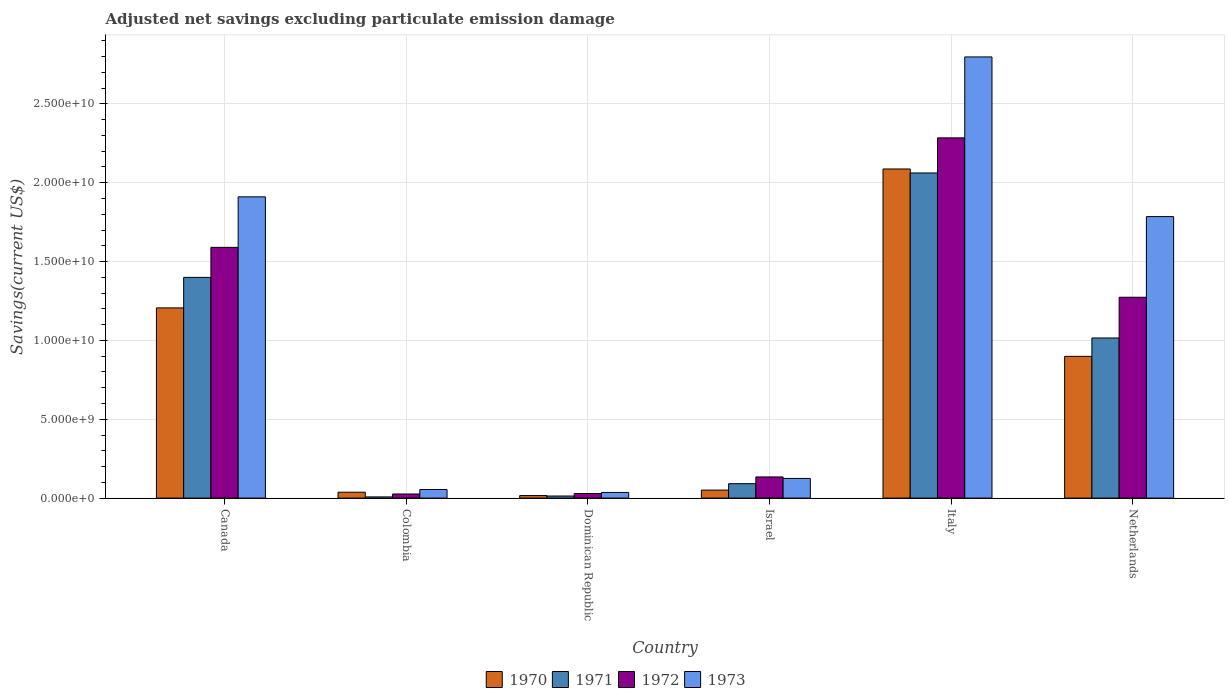How many groups of bars are there?
Your answer should be compact. 6. How many bars are there on the 5th tick from the left?
Provide a succinct answer. 4. What is the label of the 5th group of bars from the left?
Give a very brief answer. Italy. In how many cases, is the number of bars for a given country not equal to the number of legend labels?
Offer a very short reply. 0. What is the adjusted net savings in 1971 in Israel?
Keep it short and to the point. 9.14e+08. Across all countries, what is the maximum adjusted net savings in 1972?
Provide a short and direct response. 2.28e+1. Across all countries, what is the minimum adjusted net savings in 1972?
Your answer should be compact. 2.60e+08. In which country was the adjusted net savings in 1970 minimum?
Provide a short and direct response. Dominican Republic. What is the total adjusted net savings in 1973 in the graph?
Make the answer very short. 6.71e+1. What is the difference between the adjusted net savings in 1971 in Dominican Republic and that in Italy?
Make the answer very short. -2.05e+1. What is the difference between the adjusted net savings in 1971 in Netherlands and the adjusted net savings in 1970 in Colombia?
Offer a very short reply. 9.78e+09. What is the average adjusted net savings in 1973 per country?
Ensure brevity in your answer.  1.12e+1. What is the difference between the adjusted net savings of/in 1972 and adjusted net savings of/in 1970 in Canada?
Provide a short and direct response. 3.84e+09. What is the ratio of the adjusted net savings in 1973 in Israel to that in Italy?
Provide a succinct answer. 0.04. Is the adjusted net savings in 1971 in Canada less than that in Netherlands?
Make the answer very short. No. Is the difference between the adjusted net savings in 1972 in Italy and Netherlands greater than the difference between the adjusted net savings in 1970 in Italy and Netherlands?
Your response must be concise. No. What is the difference between the highest and the second highest adjusted net savings in 1972?
Ensure brevity in your answer.  1.01e+1. What is the difference between the highest and the lowest adjusted net savings in 1970?
Give a very brief answer. 2.07e+1. In how many countries, is the adjusted net savings in 1971 greater than the average adjusted net savings in 1971 taken over all countries?
Provide a short and direct response. 3. Is the sum of the adjusted net savings in 1973 in Colombia and Israel greater than the maximum adjusted net savings in 1972 across all countries?
Make the answer very short. No. What does the 2nd bar from the left in Colombia represents?
Make the answer very short. 1971. Is it the case that in every country, the sum of the adjusted net savings in 1972 and adjusted net savings in 1971 is greater than the adjusted net savings in 1973?
Your answer should be compact. No. How many bars are there?
Provide a succinct answer. 24. Where does the legend appear in the graph?
Provide a succinct answer. Bottom center. How many legend labels are there?
Your response must be concise. 4. What is the title of the graph?
Keep it short and to the point. Adjusted net savings excluding particulate emission damage. What is the label or title of the Y-axis?
Give a very brief answer. Savings(current US$). What is the Savings(current US$) of 1970 in Canada?
Offer a terse response. 1.21e+1. What is the Savings(current US$) in 1971 in Canada?
Give a very brief answer. 1.40e+1. What is the Savings(current US$) in 1972 in Canada?
Offer a very short reply. 1.59e+1. What is the Savings(current US$) in 1973 in Canada?
Make the answer very short. 1.91e+1. What is the Savings(current US$) of 1970 in Colombia?
Give a very brief answer. 3.74e+08. What is the Savings(current US$) of 1971 in Colombia?
Your answer should be compact. 7.46e+07. What is the Savings(current US$) in 1972 in Colombia?
Offer a terse response. 2.60e+08. What is the Savings(current US$) in 1973 in Colombia?
Make the answer very short. 5.45e+08. What is the Savings(current US$) of 1970 in Dominican Republic?
Provide a succinct answer. 1.61e+08. What is the Savings(current US$) of 1971 in Dominican Republic?
Keep it short and to the point. 1.32e+08. What is the Savings(current US$) in 1972 in Dominican Republic?
Provide a short and direct response. 2.89e+08. What is the Savings(current US$) of 1973 in Dominican Republic?
Your response must be concise. 3.58e+08. What is the Savings(current US$) of 1970 in Israel?
Make the answer very short. 5.08e+08. What is the Savings(current US$) of 1971 in Israel?
Make the answer very short. 9.14e+08. What is the Savings(current US$) of 1972 in Israel?
Your response must be concise. 1.34e+09. What is the Savings(current US$) of 1973 in Israel?
Give a very brief answer. 1.25e+09. What is the Savings(current US$) of 1970 in Italy?
Make the answer very short. 2.09e+1. What is the Savings(current US$) in 1971 in Italy?
Provide a succinct answer. 2.06e+1. What is the Savings(current US$) of 1972 in Italy?
Offer a very short reply. 2.28e+1. What is the Savings(current US$) of 1973 in Italy?
Provide a succinct answer. 2.80e+1. What is the Savings(current US$) of 1970 in Netherlands?
Your answer should be compact. 8.99e+09. What is the Savings(current US$) in 1971 in Netherlands?
Provide a succinct answer. 1.02e+1. What is the Savings(current US$) in 1972 in Netherlands?
Make the answer very short. 1.27e+1. What is the Savings(current US$) of 1973 in Netherlands?
Provide a short and direct response. 1.79e+1. Across all countries, what is the maximum Savings(current US$) of 1970?
Offer a very short reply. 2.09e+1. Across all countries, what is the maximum Savings(current US$) in 1971?
Ensure brevity in your answer.  2.06e+1. Across all countries, what is the maximum Savings(current US$) of 1972?
Ensure brevity in your answer.  2.28e+1. Across all countries, what is the maximum Savings(current US$) of 1973?
Offer a very short reply. 2.80e+1. Across all countries, what is the minimum Savings(current US$) of 1970?
Provide a short and direct response. 1.61e+08. Across all countries, what is the minimum Savings(current US$) of 1971?
Give a very brief answer. 7.46e+07. Across all countries, what is the minimum Savings(current US$) of 1972?
Your answer should be compact. 2.60e+08. Across all countries, what is the minimum Savings(current US$) of 1973?
Offer a terse response. 3.58e+08. What is the total Savings(current US$) of 1970 in the graph?
Make the answer very short. 4.30e+1. What is the total Savings(current US$) in 1971 in the graph?
Your response must be concise. 4.59e+1. What is the total Savings(current US$) in 1972 in the graph?
Your answer should be compact. 5.34e+1. What is the total Savings(current US$) in 1973 in the graph?
Provide a succinct answer. 6.71e+1. What is the difference between the Savings(current US$) of 1970 in Canada and that in Colombia?
Give a very brief answer. 1.17e+1. What is the difference between the Savings(current US$) in 1971 in Canada and that in Colombia?
Make the answer very short. 1.39e+1. What is the difference between the Savings(current US$) of 1972 in Canada and that in Colombia?
Your answer should be compact. 1.56e+1. What is the difference between the Savings(current US$) in 1973 in Canada and that in Colombia?
Offer a terse response. 1.86e+1. What is the difference between the Savings(current US$) of 1970 in Canada and that in Dominican Republic?
Your response must be concise. 1.19e+1. What is the difference between the Savings(current US$) of 1971 in Canada and that in Dominican Republic?
Ensure brevity in your answer.  1.39e+1. What is the difference between the Savings(current US$) in 1972 in Canada and that in Dominican Republic?
Make the answer very short. 1.56e+1. What is the difference between the Savings(current US$) in 1973 in Canada and that in Dominican Republic?
Offer a terse response. 1.87e+1. What is the difference between the Savings(current US$) of 1970 in Canada and that in Israel?
Your response must be concise. 1.16e+1. What is the difference between the Savings(current US$) in 1971 in Canada and that in Israel?
Your answer should be compact. 1.31e+1. What is the difference between the Savings(current US$) of 1972 in Canada and that in Israel?
Your response must be concise. 1.46e+1. What is the difference between the Savings(current US$) of 1973 in Canada and that in Israel?
Offer a terse response. 1.79e+1. What is the difference between the Savings(current US$) in 1970 in Canada and that in Italy?
Ensure brevity in your answer.  -8.81e+09. What is the difference between the Savings(current US$) in 1971 in Canada and that in Italy?
Offer a very short reply. -6.62e+09. What is the difference between the Savings(current US$) of 1972 in Canada and that in Italy?
Provide a succinct answer. -6.94e+09. What is the difference between the Savings(current US$) of 1973 in Canada and that in Italy?
Make the answer very short. -8.87e+09. What is the difference between the Savings(current US$) in 1970 in Canada and that in Netherlands?
Offer a terse response. 3.07e+09. What is the difference between the Savings(current US$) in 1971 in Canada and that in Netherlands?
Your answer should be compact. 3.84e+09. What is the difference between the Savings(current US$) of 1972 in Canada and that in Netherlands?
Keep it short and to the point. 3.16e+09. What is the difference between the Savings(current US$) in 1973 in Canada and that in Netherlands?
Offer a very short reply. 1.25e+09. What is the difference between the Savings(current US$) of 1970 in Colombia and that in Dominican Republic?
Your answer should be compact. 2.13e+08. What is the difference between the Savings(current US$) in 1971 in Colombia and that in Dominican Republic?
Provide a short and direct response. -5.69e+07. What is the difference between the Savings(current US$) in 1972 in Colombia and that in Dominican Republic?
Offer a terse response. -2.84e+07. What is the difference between the Savings(current US$) in 1973 in Colombia and that in Dominican Republic?
Your answer should be very brief. 1.87e+08. What is the difference between the Savings(current US$) of 1970 in Colombia and that in Israel?
Your answer should be very brief. -1.34e+08. What is the difference between the Savings(current US$) in 1971 in Colombia and that in Israel?
Provide a short and direct response. -8.40e+08. What is the difference between the Savings(current US$) in 1972 in Colombia and that in Israel?
Your answer should be compact. -1.08e+09. What is the difference between the Savings(current US$) in 1973 in Colombia and that in Israel?
Offer a terse response. -7.02e+08. What is the difference between the Savings(current US$) of 1970 in Colombia and that in Italy?
Your answer should be very brief. -2.05e+1. What is the difference between the Savings(current US$) of 1971 in Colombia and that in Italy?
Make the answer very short. -2.05e+1. What is the difference between the Savings(current US$) of 1972 in Colombia and that in Italy?
Keep it short and to the point. -2.26e+1. What is the difference between the Savings(current US$) in 1973 in Colombia and that in Italy?
Keep it short and to the point. -2.74e+1. What is the difference between the Savings(current US$) of 1970 in Colombia and that in Netherlands?
Offer a very short reply. -8.61e+09. What is the difference between the Savings(current US$) in 1971 in Colombia and that in Netherlands?
Your answer should be compact. -1.01e+1. What is the difference between the Savings(current US$) in 1972 in Colombia and that in Netherlands?
Your answer should be compact. -1.25e+1. What is the difference between the Savings(current US$) of 1973 in Colombia and that in Netherlands?
Provide a short and direct response. -1.73e+1. What is the difference between the Savings(current US$) of 1970 in Dominican Republic and that in Israel?
Offer a terse response. -3.47e+08. What is the difference between the Savings(current US$) of 1971 in Dominican Republic and that in Israel?
Ensure brevity in your answer.  -7.83e+08. What is the difference between the Savings(current US$) of 1972 in Dominican Republic and that in Israel?
Make the answer very short. -1.05e+09. What is the difference between the Savings(current US$) in 1973 in Dominican Republic and that in Israel?
Keep it short and to the point. -8.89e+08. What is the difference between the Savings(current US$) in 1970 in Dominican Republic and that in Italy?
Offer a terse response. -2.07e+1. What is the difference between the Savings(current US$) of 1971 in Dominican Republic and that in Italy?
Keep it short and to the point. -2.05e+1. What is the difference between the Savings(current US$) in 1972 in Dominican Republic and that in Italy?
Ensure brevity in your answer.  -2.26e+1. What is the difference between the Savings(current US$) in 1973 in Dominican Republic and that in Italy?
Your answer should be compact. -2.76e+1. What is the difference between the Savings(current US$) in 1970 in Dominican Republic and that in Netherlands?
Ensure brevity in your answer.  -8.83e+09. What is the difference between the Savings(current US$) of 1971 in Dominican Republic and that in Netherlands?
Give a very brief answer. -1.00e+1. What is the difference between the Savings(current US$) in 1972 in Dominican Republic and that in Netherlands?
Your response must be concise. -1.24e+1. What is the difference between the Savings(current US$) of 1973 in Dominican Republic and that in Netherlands?
Your answer should be compact. -1.75e+1. What is the difference between the Savings(current US$) of 1970 in Israel and that in Italy?
Your answer should be compact. -2.04e+1. What is the difference between the Savings(current US$) of 1971 in Israel and that in Italy?
Offer a very short reply. -1.97e+1. What is the difference between the Savings(current US$) of 1972 in Israel and that in Italy?
Ensure brevity in your answer.  -2.15e+1. What is the difference between the Savings(current US$) of 1973 in Israel and that in Italy?
Provide a succinct answer. -2.67e+1. What is the difference between the Savings(current US$) of 1970 in Israel and that in Netherlands?
Ensure brevity in your answer.  -8.48e+09. What is the difference between the Savings(current US$) in 1971 in Israel and that in Netherlands?
Offer a very short reply. -9.24e+09. What is the difference between the Savings(current US$) of 1972 in Israel and that in Netherlands?
Your answer should be very brief. -1.14e+1. What is the difference between the Savings(current US$) of 1973 in Israel and that in Netherlands?
Offer a very short reply. -1.66e+1. What is the difference between the Savings(current US$) in 1970 in Italy and that in Netherlands?
Keep it short and to the point. 1.19e+1. What is the difference between the Savings(current US$) in 1971 in Italy and that in Netherlands?
Make the answer very short. 1.05e+1. What is the difference between the Savings(current US$) in 1972 in Italy and that in Netherlands?
Provide a succinct answer. 1.01e+1. What is the difference between the Savings(current US$) of 1973 in Italy and that in Netherlands?
Keep it short and to the point. 1.01e+1. What is the difference between the Savings(current US$) of 1970 in Canada and the Savings(current US$) of 1971 in Colombia?
Make the answer very short. 1.20e+1. What is the difference between the Savings(current US$) in 1970 in Canada and the Savings(current US$) in 1972 in Colombia?
Give a very brief answer. 1.18e+1. What is the difference between the Savings(current US$) of 1970 in Canada and the Savings(current US$) of 1973 in Colombia?
Your answer should be very brief. 1.15e+1. What is the difference between the Savings(current US$) in 1971 in Canada and the Savings(current US$) in 1972 in Colombia?
Your answer should be compact. 1.37e+1. What is the difference between the Savings(current US$) of 1971 in Canada and the Savings(current US$) of 1973 in Colombia?
Provide a succinct answer. 1.35e+1. What is the difference between the Savings(current US$) in 1972 in Canada and the Savings(current US$) in 1973 in Colombia?
Offer a terse response. 1.54e+1. What is the difference between the Savings(current US$) of 1970 in Canada and the Savings(current US$) of 1971 in Dominican Republic?
Offer a very short reply. 1.19e+1. What is the difference between the Savings(current US$) of 1970 in Canada and the Savings(current US$) of 1972 in Dominican Republic?
Keep it short and to the point. 1.18e+1. What is the difference between the Savings(current US$) in 1970 in Canada and the Savings(current US$) in 1973 in Dominican Republic?
Your answer should be very brief. 1.17e+1. What is the difference between the Savings(current US$) of 1971 in Canada and the Savings(current US$) of 1972 in Dominican Republic?
Your answer should be compact. 1.37e+1. What is the difference between the Savings(current US$) in 1971 in Canada and the Savings(current US$) in 1973 in Dominican Republic?
Ensure brevity in your answer.  1.36e+1. What is the difference between the Savings(current US$) in 1972 in Canada and the Savings(current US$) in 1973 in Dominican Republic?
Offer a terse response. 1.55e+1. What is the difference between the Savings(current US$) in 1970 in Canada and the Savings(current US$) in 1971 in Israel?
Your response must be concise. 1.11e+1. What is the difference between the Savings(current US$) in 1970 in Canada and the Savings(current US$) in 1972 in Israel?
Offer a terse response. 1.07e+1. What is the difference between the Savings(current US$) in 1970 in Canada and the Savings(current US$) in 1973 in Israel?
Give a very brief answer. 1.08e+1. What is the difference between the Savings(current US$) of 1971 in Canada and the Savings(current US$) of 1972 in Israel?
Keep it short and to the point. 1.27e+1. What is the difference between the Savings(current US$) of 1971 in Canada and the Savings(current US$) of 1973 in Israel?
Give a very brief answer. 1.27e+1. What is the difference between the Savings(current US$) of 1972 in Canada and the Savings(current US$) of 1973 in Israel?
Provide a short and direct response. 1.47e+1. What is the difference between the Savings(current US$) of 1970 in Canada and the Savings(current US$) of 1971 in Italy?
Ensure brevity in your answer.  -8.56e+09. What is the difference between the Savings(current US$) in 1970 in Canada and the Savings(current US$) in 1972 in Italy?
Offer a terse response. -1.08e+1. What is the difference between the Savings(current US$) of 1970 in Canada and the Savings(current US$) of 1973 in Italy?
Provide a succinct answer. -1.59e+1. What is the difference between the Savings(current US$) of 1971 in Canada and the Savings(current US$) of 1972 in Italy?
Your response must be concise. -8.85e+09. What is the difference between the Savings(current US$) in 1971 in Canada and the Savings(current US$) in 1973 in Italy?
Ensure brevity in your answer.  -1.40e+1. What is the difference between the Savings(current US$) in 1972 in Canada and the Savings(current US$) in 1973 in Italy?
Ensure brevity in your answer.  -1.21e+1. What is the difference between the Savings(current US$) of 1970 in Canada and the Savings(current US$) of 1971 in Netherlands?
Provide a short and direct response. 1.91e+09. What is the difference between the Savings(current US$) in 1970 in Canada and the Savings(current US$) in 1972 in Netherlands?
Provide a succinct answer. -6.74e+08. What is the difference between the Savings(current US$) of 1970 in Canada and the Savings(current US$) of 1973 in Netherlands?
Offer a very short reply. -5.79e+09. What is the difference between the Savings(current US$) in 1971 in Canada and the Savings(current US$) in 1972 in Netherlands?
Ensure brevity in your answer.  1.26e+09. What is the difference between the Savings(current US$) in 1971 in Canada and the Savings(current US$) in 1973 in Netherlands?
Offer a terse response. -3.85e+09. What is the difference between the Savings(current US$) of 1972 in Canada and the Savings(current US$) of 1973 in Netherlands?
Keep it short and to the point. -1.95e+09. What is the difference between the Savings(current US$) in 1970 in Colombia and the Savings(current US$) in 1971 in Dominican Republic?
Offer a terse response. 2.42e+08. What is the difference between the Savings(current US$) in 1970 in Colombia and the Savings(current US$) in 1972 in Dominican Republic?
Ensure brevity in your answer.  8.52e+07. What is the difference between the Savings(current US$) in 1970 in Colombia and the Savings(current US$) in 1973 in Dominican Republic?
Your response must be concise. 1.57e+07. What is the difference between the Savings(current US$) of 1971 in Colombia and the Savings(current US$) of 1972 in Dominican Republic?
Your response must be concise. -2.14e+08. What is the difference between the Savings(current US$) in 1971 in Colombia and the Savings(current US$) in 1973 in Dominican Republic?
Your answer should be very brief. -2.84e+08. What is the difference between the Savings(current US$) of 1972 in Colombia and the Savings(current US$) of 1973 in Dominican Republic?
Your response must be concise. -9.79e+07. What is the difference between the Savings(current US$) in 1970 in Colombia and the Savings(current US$) in 1971 in Israel?
Your response must be concise. -5.40e+08. What is the difference between the Savings(current US$) in 1970 in Colombia and the Savings(current US$) in 1972 in Israel?
Your answer should be very brief. -9.67e+08. What is the difference between the Savings(current US$) of 1970 in Colombia and the Savings(current US$) of 1973 in Israel?
Your response must be concise. -8.73e+08. What is the difference between the Savings(current US$) of 1971 in Colombia and the Savings(current US$) of 1972 in Israel?
Keep it short and to the point. -1.27e+09. What is the difference between the Savings(current US$) in 1971 in Colombia and the Savings(current US$) in 1973 in Israel?
Your answer should be very brief. -1.17e+09. What is the difference between the Savings(current US$) in 1972 in Colombia and the Savings(current US$) in 1973 in Israel?
Give a very brief answer. -9.87e+08. What is the difference between the Savings(current US$) of 1970 in Colombia and the Savings(current US$) of 1971 in Italy?
Provide a short and direct response. -2.02e+1. What is the difference between the Savings(current US$) of 1970 in Colombia and the Savings(current US$) of 1972 in Italy?
Keep it short and to the point. -2.25e+1. What is the difference between the Savings(current US$) of 1970 in Colombia and the Savings(current US$) of 1973 in Italy?
Make the answer very short. -2.76e+1. What is the difference between the Savings(current US$) in 1971 in Colombia and the Savings(current US$) in 1972 in Italy?
Offer a very short reply. -2.28e+1. What is the difference between the Savings(current US$) in 1971 in Colombia and the Savings(current US$) in 1973 in Italy?
Provide a succinct answer. -2.79e+1. What is the difference between the Savings(current US$) in 1972 in Colombia and the Savings(current US$) in 1973 in Italy?
Ensure brevity in your answer.  -2.77e+1. What is the difference between the Savings(current US$) of 1970 in Colombia and the Savings(current US$) of 1971 in Netherlands?
Provide a short and direct response. -9.78e+09. What is the difference between the Savings(current US$) of 1970 in Colombia and the Savings(current US$) of 1972 in Netherlands?
Provide a short and direct response. -1.24e+1. What is the difference between the Savings(current US$) in 1970 in Colombia and the Savings(current US$) in 1973 in Netherlands?
Keep it short and to the point. -1.75e+1. What is the difference between the Savings(current US$) of 1971 in Colombia and the Savings(current US$) of 1972 in Netherlands?
Your response must be concise. -1.27e+1. What is the difference between the Savings(current US$) of 1971 in Colombia and the Savings(current US$) of 1973 in Netherlands?
Ensure brevity in your answer.  -1.78e+1. What is the difference between the Savings(current US$) in 1972 in Colombia and the Savings(current US$) in 1973 in Netherlands?
Provide a short and direct response. -1.76e+1. What is the difference between the Savings(current US$) of 1970 in Dominican Republic and the Savings(current US$) of 1971 in Israel?
Your answer should be very brief. -7.53e+08. What is the difference between the Savings(current US$) in 1970 in Dominican Republic and the Savings(current US$) in 1972 in Israel?
Offer a terse response. -1.18e+09. What is the difference between the Savings(current US$) in 1970 in Dominican Republic and the Savings(current US$) in 1973 in Israel?
Ensure brevity in your answer.  -1.09e+09. What is the difference between the Savings(current US$) in 1971 in Dominican Republic and the Savings(current US$) in 1972 in Israel?
Ensure brevity in your answer.  -1.21e+09. What is the difference between the Savings(current US$) in 1971 in Dominican Republic and the Savings(current US$) in 1973 in Israel?
Give a very brief answer. -1.12e+09. What is the difference between the Savings(current US$) of 1972 in Dominican Republic and the Savings(current US$) of 1973 in Israel?
Keep it short and to the point. -9.58e+08. What is the difference between the Savings(current US$) of 1970 in Dominican Republic and the Savings(current US$) of 1971 in Italy?
Your answer should be very brief. -2.05e+1. What is the difference between the Savings(current US$) in 1970 in Dominican Republic and the Savings(current US$) in 1972 in Italy?
Provide a succinct answer. -2.27e+1. What is the difference between the Savings(current US$) of 1970 in Dominican Republic and the Savings(current US$) of 1973 in Italy?
Provide a succinct answer. -2.78e+1. What is the difference between the Savings(current US$) in 1971 in Dominican Republic and the Savings(current US$) in 1972 in Italy?
Your response must be concise. -2.27e+1. What is the difference between the Savings(current US$) of 1971 in Dominican Republic and the Savings(current US$) of 1973 in Italy?
Offer a terse response. -2.78e+1. What is the difference between the Savings(current US$) in 1972 in Dominican Republic and the Savings(current US$) in 1973 in Italy?
Offer a very short reply. -2.77e+1. What is the difference between the Savings(current US$) of 1970 in Dominican Republic and the Savings(current US$) of 1971 in Netherlands?
Your response must be concise. -9.99e+09. What is the difference between the Savings(current US$) of 1970 in Dominican Republic and the Savings(current US$) of 1972 in Netherlands?
Ensure brevity in your answer.  -1.26e+1. What is the difference between the Savings(current US$) in 1970 in Dominican Republic and the Savings(current US$) in 1973 in Netherlands?
Provide a succinct answer. -1.77e+1. What is the difference between the Savings(current US$) of 1971 in Dominican Republic and the Savings(current US$) of 1972 in Netherlands?
Your answer should be compact. -1.26e+1. What is the difference between the Savings(current US$) in 1971 in Dominican Republic and the Savings(current US$) in 1973 in Netherlands?
Give a very brief answer. -1.77e+1. What is the difference between the Savings(current US$) in 1972 in Dominican Republic and the Savings(current US$) in 1973 in Netherlands?
Provide a short and direct response. -1.76e+1. What is the difference between the Savings(current US$) in 1970 in Israel and the Savings(current US$) in 1971 in Italy?
Your answer should be very brief. -2.01e+1. What is the difference between the Savings(current US$) of 1970 in Israel and the Savings(current US$) of 1972 in Italy?
Keep it short and to the point. -2.23e+1. What is the difference between the Savings(current US$) of 1970 in Israel and the Savings(current US$) of 1973 in Italy?
Provide a succinct answer. -2.75e+1. What is the difference between the Savings(current US$) in 1971 in Israel and the Savings(current US$) in 1972 in Italy?
Your answer should be very brief. -2.19e+1. What is the difference between the Savings(current US$) in 1971 in Israel and the Savings(current US$) in 1973 in Italy?
Keep it short and to the point. -2.71e+1. What is the difference between the Savings(current US$) of 1972 in Israel and the Savings(current US$) of 1973 in Italy?
Offer a terse response. -2.66e+1. What is the difference between the Savings(current US$) of 1970 in Israel and the Savings(current US$) of 1971 in Netherlands?
Keep it short and to the point. -9.65e+09. What is the difference between the Savings(current US$) of 1970 in Israel and the Savings(current US$) of 1972 in Netherlands?
Offer a terse response. -1.22e+1. What is the difference between the Savings(current US$) in 1970 in Israel and the Savings(current US$) in 1973 in Netherlands?
Provide a short and direct response. -1.73e+1. What is the difference between the Savings(current US$) of 1971 in Israel and the Savings(current US$) of 1972 in Netherlands?
Your answer should be compact. -1.18e+1. What is the difference between the Savings(current US$) of 1971 in Israel and the Savings(current US$) of 1973 in Netherlands?
Make the answer very short. -1.69e+1. What is the difference between the Savings(current US$) of 1972 in Israel and the Savings(current US$) of 1973 in Netherlands?
Provide a succinct answer. -1.65e+1. What is the difference between the Savings(current US$) of 1970 in Italy and the Savings(current US$) of 1971 in Netherlands?
Provide a succinct answer. 1.07e+1. What is the difference between the Savings(current US$) in 1970 in Italy and the Savings(current US$) in 1972 in Netherlands?
Your answer should be very brief. 8.14e+09. What is the difference between the Savings(current US$) in 1970 in Italy and the Savings(current US$) in 1973 in Netherlands?
Give a very brief answer. 3.02e+09. What is the difference between the Savings(current US$) in 1971 in Italy and the Savings(current US$) in 1972 in Netherlands?
Ensure brevity in your answer.  7.88e+09. What is the difference between the Savings(current US$) in 1971 in Italy and the Savings(current US$) in 1973 in Netherlands?
Your answer should be very brief. 2.77e+09. What is the difference between the Savings(current US$) in 1972 in Italy and the Savings(current US$) in 1973 in Netherlands?
Ensure brevity in your answer.  4.99e+09. What is the average Savings(current US$) of 1970 per country?
Give a very brief answer. 7.16e+09. What is the average Savings(current US$) in 1971 per country?
Offer a terse response. 7.65e+09. What is the average Savings(current US$) of 1972 per country?
Make the answer very short. 8.89e+09. What is the average Savings(current US$) in 1973 per country?
Keep it short and to the point. 1.12e+1. What is the difference between the Savings(current US$) of 1970 and Savings(current US$) of 1971 in Canada?
Your response must be concise. -1.94e+09. What is the difference between the Savings(current US$) in 1970 and Savings(current US$) in 1972 in Canada?
Keep it short and to the point. -3.84e+09. What is the difference between the Savings(current US$) in 1970 and Savings(current US$) in 1973 in Canada?
Offer a terse response. -7.04e+09. What is the difference between the Savings(current US$) in 1971 and Savings(current US$) in 1972 in Canada?
Offer a terse response. -1.90e+09. What is the difference between the Savings(current US$) in 1971 and Savings(current US$) in 1973 in Canada?
Your response must be concise. -5.11e+09. What is the difference between the Savings(current US$) of 1972 and Savings(current US$) of 1973 in Canada?
Make the answer very short. -3.20e+09. What is the difference between the Savings(current US$) of 1970 and Savings(current US$) of 1971 in Colombia?
Your answer should be compact. 2.99e+08. What is the difference between the Savings(current US$) in 1970 and Savings(current US$) in 1972 in Colombia?
Your response must be concise. 1.14e+08. What is the difference between the Savings(current US$) in 1970 and Savings(current US$) in 1973 in Colombia?
Provide a short and direct response. -1.71e+08. What is the difference between the Savings(current US$) in 1971 and Savings(current US$) in 1972 in Colombia?
Your answer should be very brief. -1.86e+08. What is the difference between the Savings(current US$) of 1971 and Savings(current US$) of 1973 in Colombia?
Offer a terse response. -4.70e+08. What is the difference between the Savings(current US$) in 1972 and Savings(current US$) in 1973 in Colombia?
Make the answer very short. -2.85e+08. What is the difference between the Savings(current US$) in 1970 and Savings(current US$) in 1971 in Dominican Republic?
Ensure brevity in your answer.  2.96e+07. What is the difference between the Savings(current US$) of 1970 and Savings(current US$) of 1972 in Dominican Republic?
Provide a succinct answer. -1.28e+08. What is the difference between the Savings(current US$) in 1970 and Savings(current US$) in 1973 in Dominican Republic?
Make the answer very short. -1.97e+08. What is the difference between the Savings(current US$) of 1971 and Savings(current US$) of 1972 in Dominican Republic?
Give a very brief answer. -1.57e+08. What is the difference between the Savings(current US$) of 1971 and Savings(current US$) of 1973 in Dominican Republic?
Your response must be concise. -2.27e+08. What is the difference between the Savings(current US$) of 1972 and Savings(current US$) of 1973 in Dominican Republic?
Your answer should be very brief. -6.95e+07. What is the difference between the Savings(current US$) of 1970 and Savings(current US$) of 1971 in Israel?
Provide a succinct answer. -4.06e+08. What is the difference between the Savings(current US$) of 1970 and Savings(current US$) of 1972 in Israel?
Keep it short and to the point. -8.33e+08. What is the difference between the Savings(current US$) in 1970 and Savings(current US$) in 1973 in Israel?
Make the answer very short. -7.39e+08. What is the difference between the Savings(current US$) in 1971 and Savings(current US$) in 1972 in Israel?
Offer a very short reply. -4.27e+08. What is the difference between the Savings(current US$) of 1971 and Savings(current US$) of 1973 in Israel?
Offer a terse response. -3.33e+08. What is the difference between the Savings(current US$) of 1972 and Savings(current US$) of 1973 in Israel?
Ensure brevity in your answer.  9.40e+07. What is the difference between the Savings(current US$) in 1970 and Savings(current US$) in 1971 in Italy?
Give a very brief answer. 2.53e+08. What is the difference between the Savings(current US$) in 1970 and Savings(current US$) in 1972 in Italy?
Your answer should be compact. -1.97e+09. What is the difference between the Savings(current US$) of 1970 and Savings(current US$) of 1973 in Italy?
Ensure brevity in your answer.  -7.11e+09. What is the difference between the Savings(current US$) in 1971 and Savings(current US$) in 1972 in Italy?
Your answer should be compact. -2.23e+09. What is the difference between the Savings(current US$) in 1971 and Savings(current US$) in 1973 in Italy?
Provide a short and direct response. -7.36e+09. What is the difference between the Savings(current US$) in 1972 and Savings(current US$) in 1973 in Italy?
Provide a succinct answer. -5.13e+09. What is the difference between the Savings(current US$) of 1970 and Savings(current US$) of 1971 in Netherlands?
Your answer should be compact. -1.17e+09. What is the difference between the Savings(current US$) in 1970 and Savings(current US$) in 1972 in Netherlands?
Provide a short and direct response. -3.75e+09. What is the difference between the Savings(current US$) in 1970 and Savings(current US$) in 1973 in Netherlands?
Provide a short and direct response. -8.86e+09. What is the difference between the Savings(current US$) in 1971 and Savings(current US$) in 1972 in Netherlands?
Your answer should be very brief. -2.58e+09. What is the difference between the Savings(current US$) of 1971 and Savings(current US$) of 1973 in Netherlands?
Make the answer very short. -7.70e+09. What is the difference between the Savings(current US$) in 1972 and Savings(current US$) in 1973 in Netherlands?
Your answer should be very brief. -5.11e+09. What is the ratio of the Savings(current US$) in 1970 in Canada to that in Colombia?
Your answer should be compact. 32.26. What is the ratio of the Savings(current US$) in 1971 in Canada to that in Colombia?
Your response must be concise. 187.59. What is the ratio of the Savings(current US$) of 1972 in Canada to that in Colombia?
Offer a terse response. 61.09. What is the ratio of the Savings(current US$) in 1973 in Canada to that in Colombia?
Give a very brief answer. 35.07. What is the ratio of the Savings(current US$) of 1970 in Canada to that in Dominican Republic?
Offer a very short reply. 74.87. What is the ratio of the Savings(current US$) of 1971 in Canada to that in Dominican Republic?
Ensure brevity in your answer.  106.4. What is the ratio of the Savings(current US$) in 1972 in Canada to that in Dominican Republic?
Your response must be concise. 55.08. What is the ratio of the Savings(current US$) in 1973 in Canada to that in Dominican Republic?
Make the answer very short. 53.33. What is the ratio of the Savings(current US$) in 1970 in Canada to that in Israel?
Keep it short and to the point. 23.75. What is the ratio of the Savings(current US$) in 1971 in Canada to that in Israel?
Keep it short and to the point. 15.31. What is the ratio of the Savings(current US$) of 1972 in Canada to that in Israel?
Provide a short and direct response. 11.86. What is the ratio of the Savings(current US$) of 1973 in Canada to that in Israel?
Your answer should be very brief. 15.32. What is the ratio of the Savings(current US$) of 1970 in Canada to that in Italy?
Your answer should be compact. 0.58. What is the ratio of the Savings(current US$) in 1971 in Canada to that in Italy?
Offer a very short reply. 0.68. What is the ratio of the Savings(current US$) in 1972 in Canada to that in Italy?
Make the answer very short. 0.7. What is the ratio of the Savings(current US$) in 1973 in Canada to that in Italy?
Keep it short and to the point. 0.68. What is the ratio of the Savings(current US$) in 1970 in Canada to that in Netherlands?
Make the answer very short. 1.34. What is the ratio of the Savings(current US$) of 1971 in Canada to that in Netherlands?
Offer a terse response. 1.38. What is the ratio of the Savings(current US$) in 1972 in Canada to that in Netherlands?
Your response must be concise. 1.25. What is the ratio of the Savings(current US$) in 1973 in Canada to that in Netherlands?
Offer a very short reply. 1.07. What is the ratio of the Savings(current US$) in 1970 in Colombia to that in Dominican Republic?
Provide a short and direct response. 2.32. What is the ratio of the Savings(current US$) in 1971 in Colombia to that in Dominican Republic?
Provide a short and direct response. 0.57. What is the ratio of the Savings(current US$) of 1972 in Colombia to that in Dominican Republic?
Your answer should be compact. 0.9. What is the ratio of the Savings(current US$) in 1973 in Colombia to that in Dominican Republic?
Offer a very short reply. 1.52. What is the ratio of the Savings(current US$) of 1970 in Colombia to that in Israel?
Give a very brief answer. 0.74. What is the ratio of the Savings(current US$) of 1971 in Colombia to that in Israel?
Your answer should be compact. 0.08. What is the ratio of the Savings(current US$) in 1972 in Colombia to that in Israel?
Offer a very short reply. 0.19. What is the ratio of the Savings(current US$) in 1973 in Colombia to that in Israel?
Make the answer very short. 0.44. What is the ratio of the Savings(current US$) of 1970 in Colombia to that in Italy?
Keep it short and to the point. 0.02. What is the ratio of the Savings(current US$) in 1971 in Colombia to that in Italy?
Keep it short and to the point. 0. What is the ratio of the Savings(current US$) in 1972 in Colombia to that in Italy?
Offer a very short reply. 0.01. What is the ratio of the Savings(current US$) of 1973 in Colombia to that in Italy?
Make the answer very short. 0.02. What is the ratio of the Savings(current US$) of 1970 in Colombia to that in Netherlands?
Offer a very short reply. 0.04. What is the ratio of the Savings(current US$) in 1971 in Colombia to that in Netherlands?
Provide a short and direct response. 0.01. What is the ratio of the Savings(current US$) of 1972 in Colombia to that in Netherlands?
Your response must be concise. 0.02. What is the ratio of the Savings(current US$) in 1973 in Colombia to that in Netherlands?
Your response must be concise. 0.03. What is the ratio of the Savings(current US$) of 1970 in Dominican Republic to that in Israel?
Your response must be concise. 0.32. What is the ratio of the Savings(current US$) of 1971 in Dominican Republic to that in Israel?
Your response must be concise. 0.14. What is the ratio of the Savings(current US$) in 1972 in Dominican Republic to that in Israel?
Provide a short and direct response. 0.22. What is the ratio of the Savings(current US$) in 1973 in Dominican Republic to that in Israel?
Ensure brevity in your answer.  0.29. What is the ratio of the Savings(current US$) of 1970 in Dominican Republic to that in Italy?
Provide a short and direct response. 0.01. What is the ratio of the Savings(current US$) of 1971 in Dominican Republic to that in Italy?
Give a very brief answer. 0.01. What is the ratio of the Savings(current US$) in 1972 in Dominican Republic to that in Italy?
Keep it short and to the point. 0.01. What is the ratio of the Savings(current US$) of 1973 in Dominican Republic to that in Italy?
Offer a terse response. 0.01. What is the ratio of the Savings(current US$) of 1970 in Dominican Republic to that in Netherlands?
Provide a short and direct response. 0.02. What is the ratio of the Savings(current US$) in 1971 in Dominican Republic to that in Netherlands?
Your response must be concise. 0.01. What is the ratio of the Savings(current US$) of 1972 in Dominican Republic to that in Netherlands?
Provide a short and direct response. 0.02. What is the ratio of the Savings(current US$) of 1973 in Dominican Republic to that in Netherlands?
Ensure brevity in your answer.  0.02. What is the ratio of the Savings(current US$) of 1970 in Israel to that in Italy?
Your answer should be compact. 0.02. What is the ratio of the Savings(current US$) of 1971 in Israel to that in Italy?
Give a very brief answer. 0.04. What is the ratio of the Savings(current US$) of 1972 in Israel to that in Italy?
Your response must be concise. 0.06. What is the ratio of the Savings(current US$) in 1973 in Israel to that in Italy?
Your response must be concise. 0.04. What is the ratio of the Savings(current US$) of 1970 in Israel to that in Netherlands?
Keep it short and to the point. 0.06. What is the ratio of the Savings(current US$) of 1971 in Israel to that in Netherlands?
Your answer should be very brief. 0.09. What is the ratio of the Savings(current US$) of 1972 in Israel to that in Netherlands?
Make the answer very short. 0.11. What is the ratio of the Savings(current US$) in 1973 in Israel to that in Netherlands?
Keep it short and to the point. 0.07. What is the ratio of the Savings(current US$) in 1970 in Italy to that in Netherlands?
Offer a terse response. 2.32. What is the ratio of the Savings(current US$) of 1971 in Italy to that in Netherlands?
Ensure brevity in your answer.  2.03. What is the ratio of the Savings(current US$) of 1972 in Italy to that in Netherlands?
Your answer should be compact. 1.79. What is the ratio of the Savings(current US$) of 1973 in Italy to that in Netherlands?
Your answer should be very brief. 1.57. What is the difference between the highest and the second highest Savings(current US$) of 1970?
Your response must be concise. 8.81e+09. What is the difference between the highest and the second highest Savings(current US$) of 1971?
Your answer should be compact. 6.62e+09. What is the difference between the highest and the second highest Savings(current US$) of 1972?
Your answer should be compact. 6.94e+09. What is the difference between the highest and the second highest Savings(current US$) in 1973?
Give a very brief answer. 8.87e+09. What is the difference between the highest and the lowest Savings(current US$) of 1970?
Your response must be concise. 2.07e+1. What is the difference between the highest and the lowest Savings(current US$) in 1971?
Offer a terse response. 2.05e+1. What is the difference between the highest and the lowest Savings(current US$) in 1972?
Offer a terse response. 2.26e+1. What is the difference between the highest and the lowest Savings(current US$) of 1973?
Ensure brevity in your answer.  2.76e+1. 